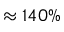Convert formula to latex. <formula><loc_0><loc_0><loc_500><loc_500>\approx 1 4 0 \%</formula> 